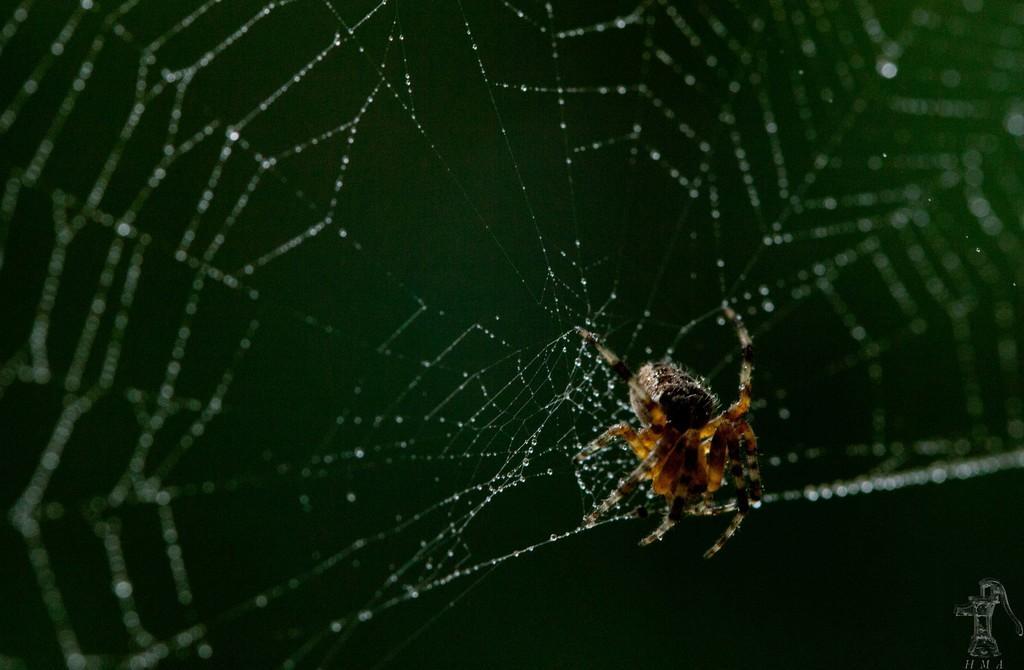Describe this image in one or two sentences. In this picture we can see an object, spider on the web and in the background it is green color. 